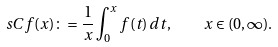Convert formula to latex. <formula><loc_0><loc_0><loc_500><loc_500>\ s C f ( x ) \colon = \frac { 1 } { x } \int _ { 0 } ^ { x } f ( t ) \, d t , \quad x \in ( 0 , \infty ) .</formula> 